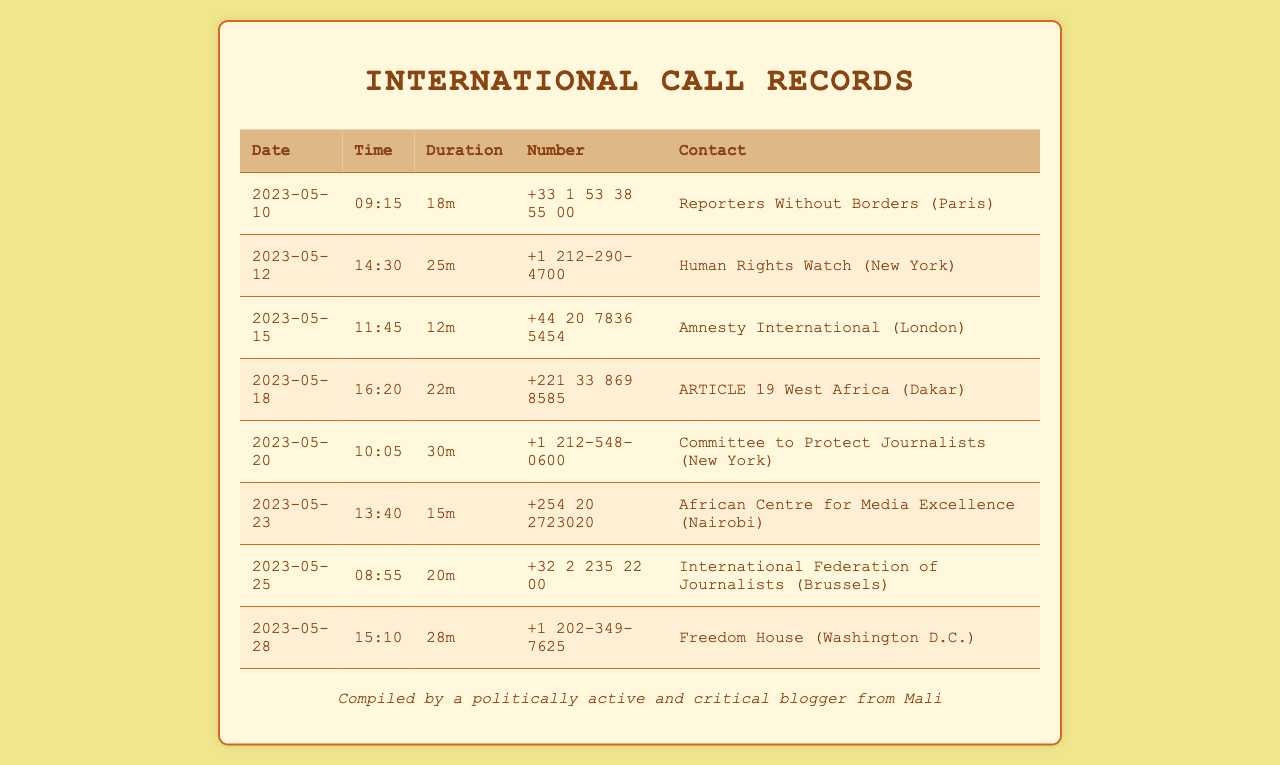What is the contact for the call on May 10, 2023? The contact for the call on this date is listed in the table as Reporters Without Borders (Paris).
Answer: Reporters Without Borders (Paris) How long was the call to Human Rights Watch? The duration of the call to Human Rights Watch on May 12, 2023, is noted in the table as 25 minutes.
Answer: 25m When was the call made to Amnesty International? According to the table, the call to Amnesty International occurred on May 15, 2023.
Answer: 2023-05-15 Which organization was contacted on May 20, 2023? The organization contacted on this date is specified in the table as Committee to Protect Journalists (New York).
Answer: Committee to Protect Journalists (New York) How many minutes did the call to ARTICLE 19 West Africa last? The duration of the call to ARTICLE 19 West Africa on May 18, 2023, is 22 minutes as shown in the document.
Answer: 22m What is the total number of calls listed in the document? The document presents a total of 8 international calls to different organizations.
Answer: 8 Which country is the number +221 33 869 8585 associated with? The country associated with this number is noted in the table as Senegal (Dakar is in Senegal).
Answer: Senegal What is the average duration of the calls documented? The average duration is calculated by taking the average of all listed durations, which results in approximately 21 minutes.
Answer: 21m 